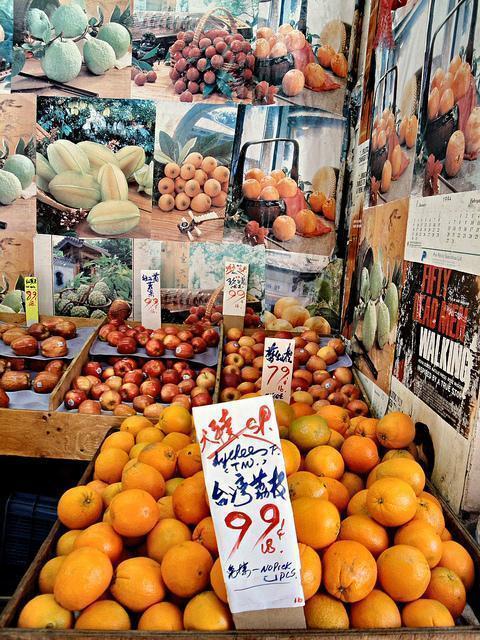How much would 2 pounds of oranges cost?
Indicate the correct choice and explain in the format: 'Answer: answer
Rationale: rationale.'
Options: 1.92, 1.63, 1.98, 1.49. Answer: 1.98.
Rationale: The sign indicates that one pound sells for 99 cents. two pounds would cost twice as much. 